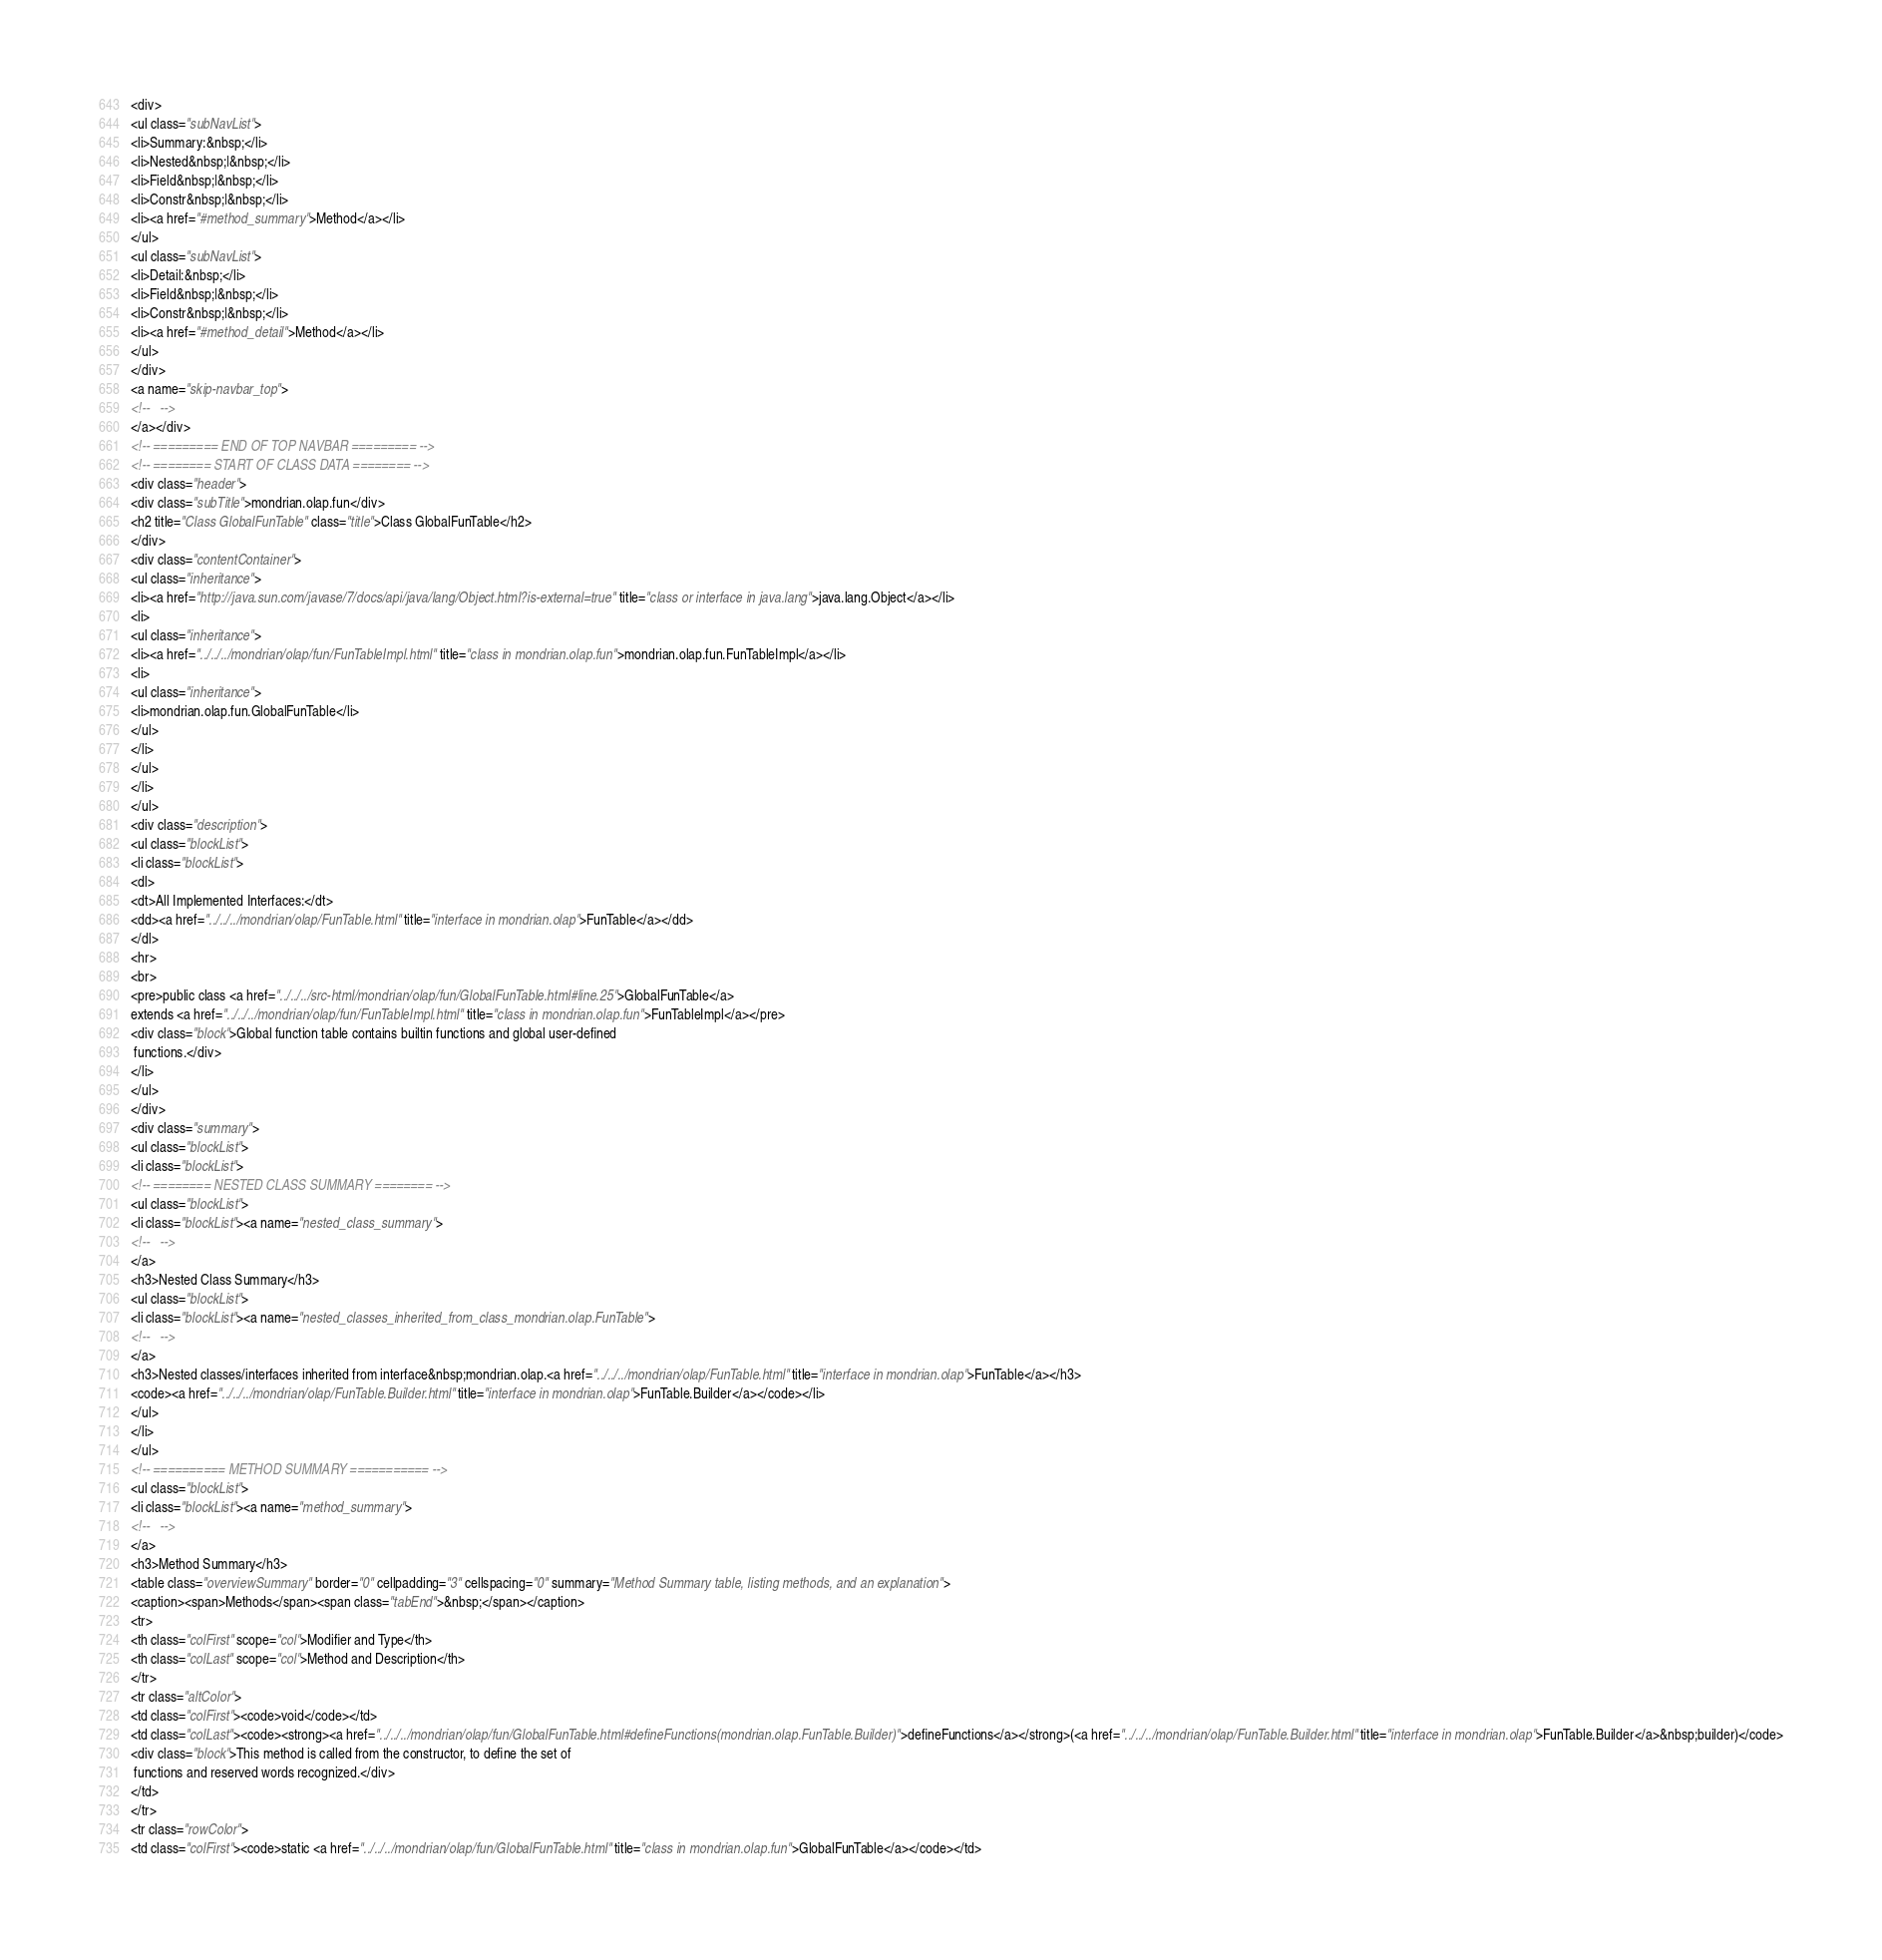Convert code to text. <code><loc_0><loc_0><loc_500><loc_500><_HTML_><div>
<ul class="subNavList">
<li>Summary:&nbsp;</li>
<li>Nested&nbsp;|&nbsp;</li>
<li>Field&nbsp;|&nbsp;</li>
<li>Constr&nbsp;|&nbsp;</li>
<li><a href="#method_summary">Method</a></li>
</ul>
<ul class="subNavList">
<li>Detail:&nbsp;</li>
<li>Field&nbsp;|&nbsp;</li>
<li>Constr&nbsp;|&nbsp;</li>
<li><a href="#method_detail">Method</a></li>
</ul>
</div>
<a name="skip-navbar_top">
<!--   -->
</a></div>
<!-- ========= END OF TOP NAVBAR ========= -->
<!-- ======== START OF CLASS DATA ======== -->
<div class="header">
<div class="subTitle">mondrian.olap.fun</div>
<h2 title="Class GlobalFunTable" class="title">Class GlobalFunTable</h2>
</div>
<div class="contentContainer">
<ul class="inheritance">
<li><a href="http://java.sun.com/javase/7/docs/api/java/lang/Object.html?is-external=true" title="class or interface in java.lang">java.lang.Object</a></li>
<li>
<ul class="inheritance">
<li><a href="../../../mondrian/olap/fun/FunTableImpl.html" title="class in mondrian.olap.fun">mondrian.olap.fun.FunTableImpl</a></li>
<li>
<ul class="inheritance">
<li>mondrian.olap.fun.GlobalFunTable</li>
</ul>
</li>
</ul>
</li>
</ul>
<div class="description">
<ul class="blockList">
<li class="blockList">
<dl>
<dt>All Implemented Interfaces:</dt>
<dd><a href="../../../mondrian/olap/FunTable.html" title="interface in mondrian.olap">FunTable</a></dd>
</dl>
<hr>
<br>
<pre>public class <a href="../../../src-html/mondrian/olap/fun/GlobalFunTable.html#line.25">GlobalFunTable</a>
extends <a href="../../../mondrian/olap/fun/FunTableImpl.html" title="class in mondrian.olap.fun">FunTableImpl</a></pre>
<div class="block">Global function table contains builtin functions and global user-defined
 functions.</div>
</li>
</ul>
</div>
<div class="summary">
<ul class="blockList">
<li class="blockList">
<!-- ======== NESTED CLASS SUMMARY ======== -->
<ul class="blockList">
<li class="blockList"><a name="nested_class_summary">
<!--   -->
</a>
<h3>Nested Class Summary</h3>
<ul class="blockList">
<li class="blockList"><a name="nested_classes_inherited_from_class_mondrian.olap.FunTable">
<!--   -->
</a>
<h3>Nested classes/interfaces inherited from interface&nbsp;mondrian.olap.<a href="../../../mondrian/olap/FunTable.html" title="interface in mondrian.olap">FunTable</a></h3>
<code><a href="../../../mondrian/olap/FunTable.Builder.html" title="interface in mondrian.olap">FunTable.Builder</a></code></li>
</ul>
</li>
</ul>
<!-- ========== METHOD SUMMARY =========== -->
<ul class="blockList">
<li class="blockList"><a name="method_summary">
<!--   -->
</a>
<h3>Method Summary</h3>
<table class="overviewSummary" border="0" cellpadding="3" cellspacing="0" summary="Method Summary table, listing methods, and an explanation">
<caption><span>Methods</span><span class="tabEnd">&nbsp;</span></caption>
<tr>
<th class="colFirst" scope="col">Modifier and Type</th>
<th class="colLast" scope="col">Method and Description</th>
</tr>
<tr class="altColor">
<td class="colFirst"><code>void</code></td>
<td class="colLast"><code><strong><a href="../../../mondrian/olap/fun/GlobalFunTable.html#defineFunctions(mondrian.olap.FunTable.Builder)">defineFunctions</a></strong>(<a href="../../../mondrian/olap/FunTable.Builder.html" title="interface in mondrian.olap">FunTable.Builder</a>&nbsp;builder)</code>
<div class="block">This method is called from the constructor, to define the set of
 functions and reserved words recognized.</div>
</td>
</tr>
<tr class="rowColor">
<td class="colFirst"><code>static <a href="../../../mondrian/olap/fun/GlobalFunTable.html" title="class in mondrian.olap.fun">GlobalFunTable</a></code></td></code> 